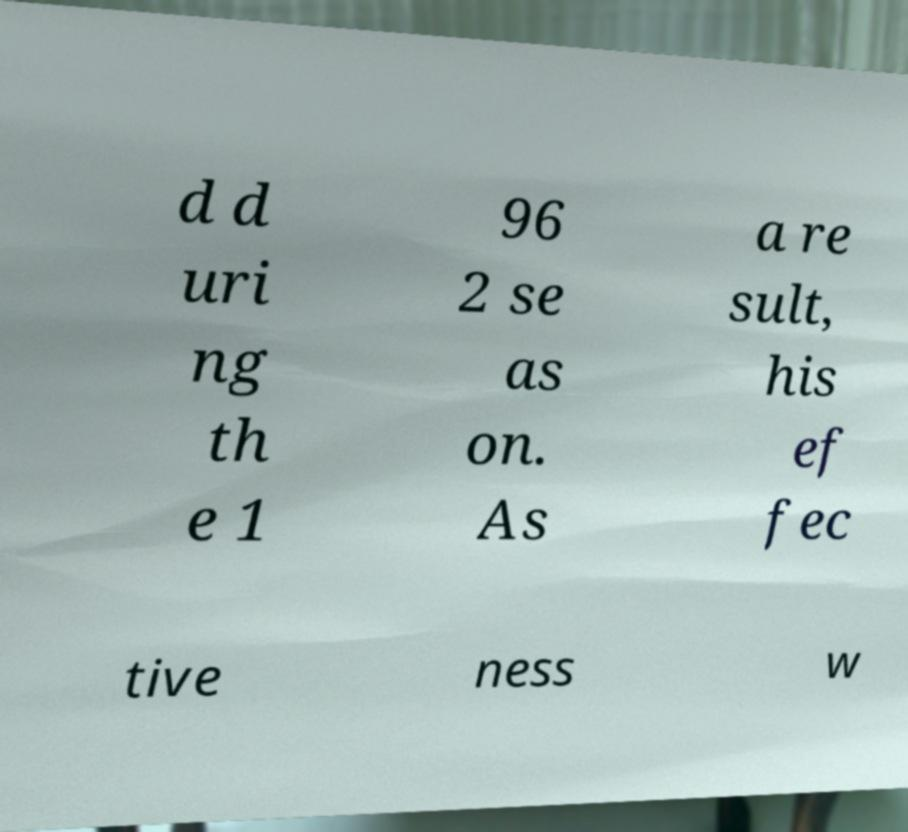Can you accurately transcribe the text from the provided image for me? d d uri ng th e 1 96 2 se as on. As a re sult, his ef fec tive ness w 